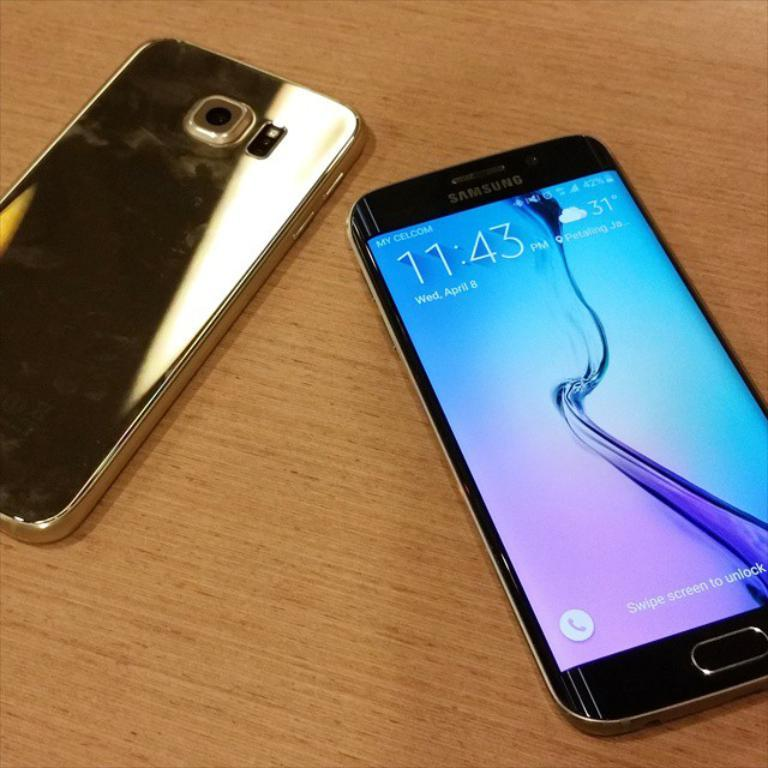<image>
Share a concise interpretation of the image provided. A Samsung smart phone displays the time and weather on its home screen. 